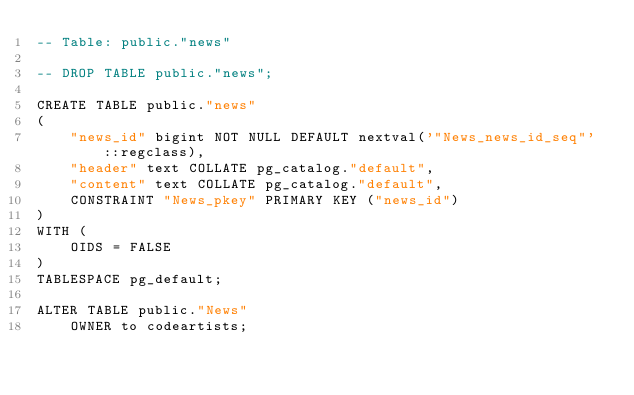Convert code to text. <code><loc_0><loc_0><loc_500><loc_500><_SQL_>-- Table: public."news"

-- DROP TABLE public."news";

CREATE TABLE public."news"
(
    "news_id" bigint NOT NULL DEFAULT nextval('"News_news_id_seq"'::regclass),
    "header" text COLLATE pg_catalog."default",
    "content" text COLLATE pg_catalog."default",
    CONSTRAINT "News_pkey" PRIMARY KEY ("news_id")
)
WITH (
    OIDS = FALSE
)
TABLESPACE pg_default;

ALTER TABLE public."News"
    OWNER to codeartists;</code> 